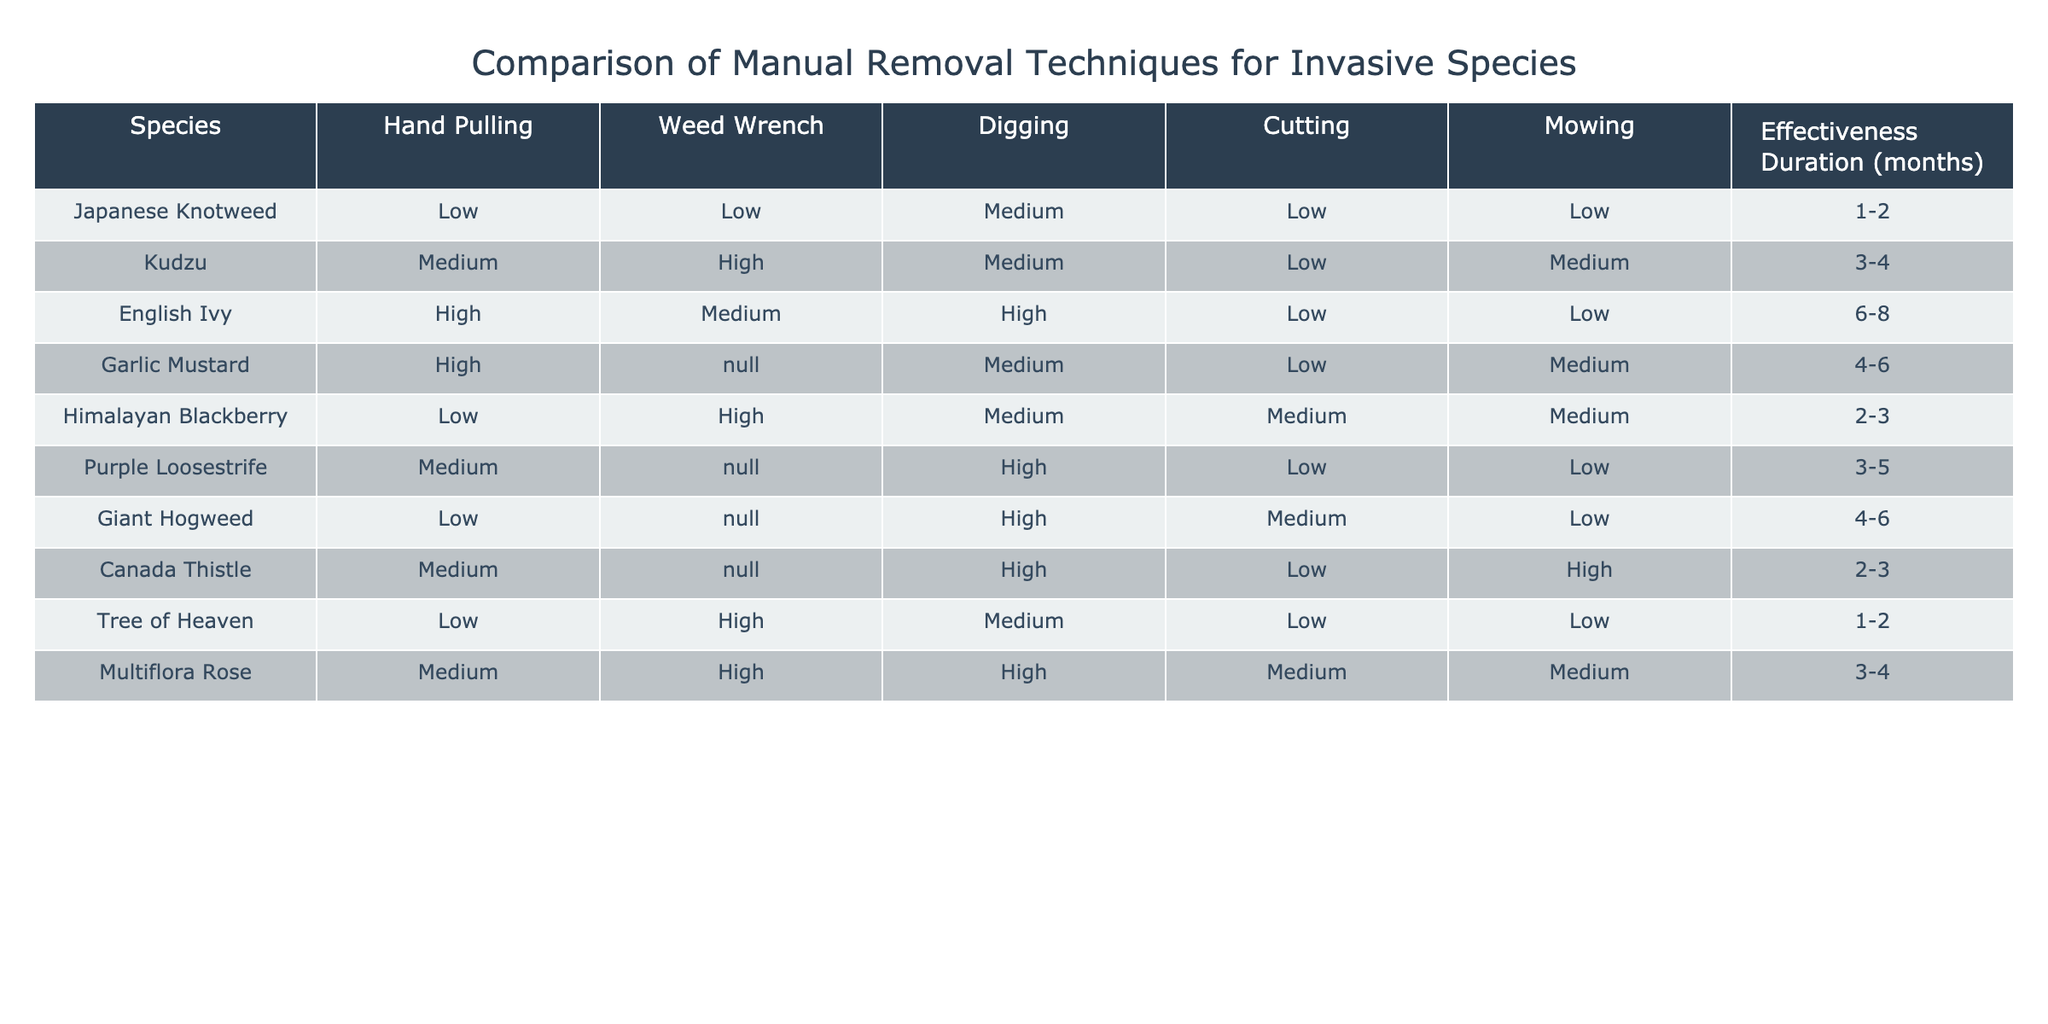What is the effectiveness duration of English Ivy removal techniques? The effectiveness duration for English Ivy is listed in the table, which indicates it lasts for 6-8 months.
Answer: 6-8 months Which invasive species can be removed most effectively using cutting? To answer this, I check the "Cutting" column for the highest effectiveness rating. English Ivy and Giant Hogweed both show "High", making them the most effective when using cutting.
Answer: English Ivy and Giant Hogweed Is the effectiveness of the Weed Wrench for kudzu high? In the table, the effectiveness of the Weed Wrench for kudzu is marked as "High". This confirms that the Weed Wrench is indeed effective for this species.
Answer: Yes What is the average effectiveness duration of all species listed? The effectiveness durations are: 1-2, 3-4, 6-8, 4-6, 2-3, 3-5, 4-6, 2-3, 1-2, and 3-4 months. For averaging, convert these ranges to their midpoints: (1.5 + 3.5 + 7 + 5 + 2.5 + 4 + 5 + 2.5 + 1.5 + 3.5) / 10 = 3.75 months.
Answer: 3.75 months For which invasion technique is the effectiveness highest across all species? I compare the effectiveness ratings across all techniques. The "High" score appears for Cutting (4 times), Weed Wrench (4 times), and Hand Pulling (3 times). However, Weed Wrench and Cutting both show very prominent effectiveness for several species, indicating they are among the most effective methods.
Answer: Weed Wrench and Cutting 